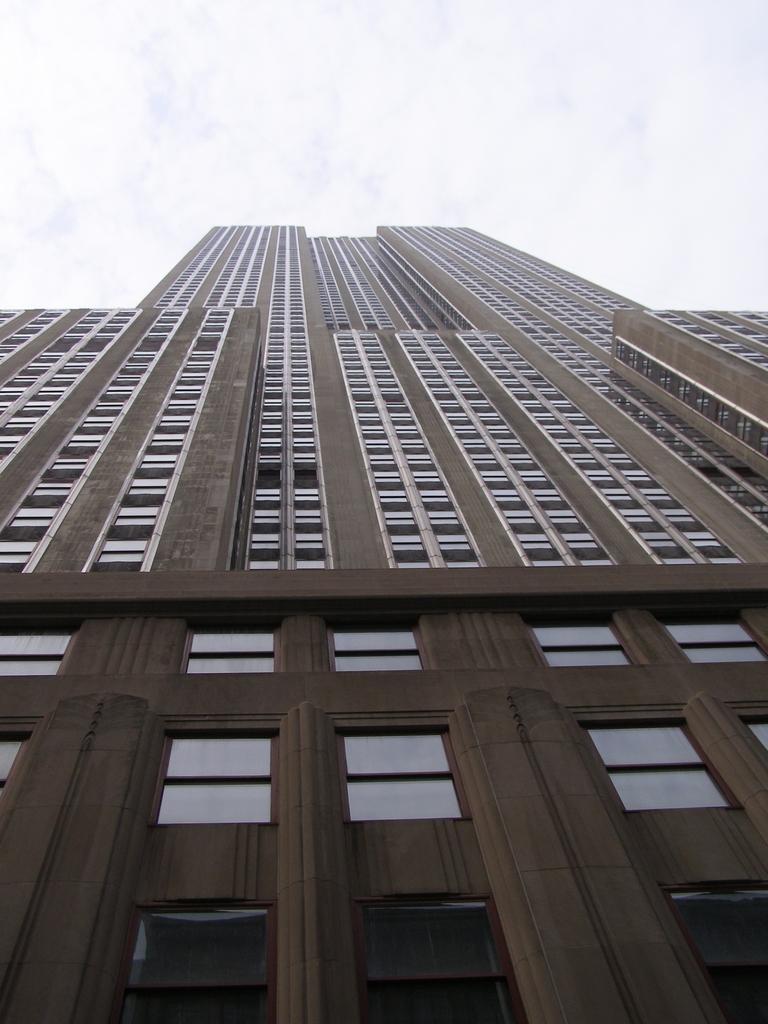Can you describe this image briefly? In this image we can see a building. On the building we can see glass windows. At the top we can see the sky. 